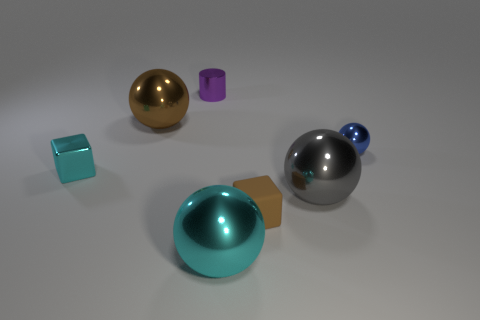Is there another metal cylinder of the same color as the tiny metal cylinder?
Provide a succinct answer. No. How many big things are either shiny cubes or green metal cylinders?
Your response must be concise. 0. How many small brown things are there?
Offer a terse response. 1. There is a cyan thing on the right side of the shiny cube; what is its material?
Give a very brief answer. Metal. Are there any gray spheres to the left of the big cyan thing?
Ensure brevity in your answer.  No. Is the size of the blue thing the same as the purple object?
Your response must be concise. Yes. How many cyan spheres are made of the same material as the big gray thing?
Your answer should be compact. 1. What size is the cyan shiny thing right of the cube behind the brown rubber thing?
Offer a very short reply. Large. The object that is both behind the big gray metallic thing and right of the tiny brown thing is what color?
Offer a very short reply. Blue. Is the tiny brown thing the same shape as the blue metallic object?
Offer a terse response. No. 